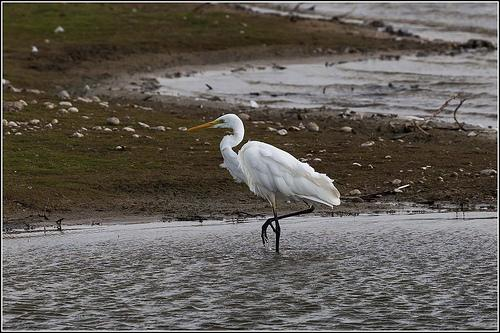Can you tell me what the bird in the image is doing? The bird is wading in the water while standing on one leg. Name the primary creature in the image along with its attributes. A white heron with a yellow beak, black legs, and a long neck. Enumerate the salient features of the bird in the image. The bird has a white body, a long yellow beak, a dark eye, and black legs with one leg bent. Identify the type of environment the bird is seen in. The bird is in a lake environment, surrounded by grass, rocks, and muddy shore. In this picture, what can you see about the appearance of the water, and how it interacts with the landscape? The water is dark with small ripples and waves, and it is flowing towards the shore, where there are rocks and grass. Please describe the appearance of the rocks and grass near the water in the image. The rocks are brown and tan, and the grass is a mix of green and brown. They both appear close to the water's edge. What are the characteristics of the shoreline in the image? The shoreline has rocks strewn about, patches of green grass, and branches. Portray the colors and attributes of the primary bird in the image. The bird is white with an orange beak, black legs, a long neck, clawed feet, and a dark eye. What elements in the image indicate that the water is flowing and dynamic? The water has ripples, waves, and is flowing towards the shore, which indicates that it is dynamic. Provide a brief overview of the scene in the image. A white heron with a yellow beak and black legs is standing in water near rocks and grass. 